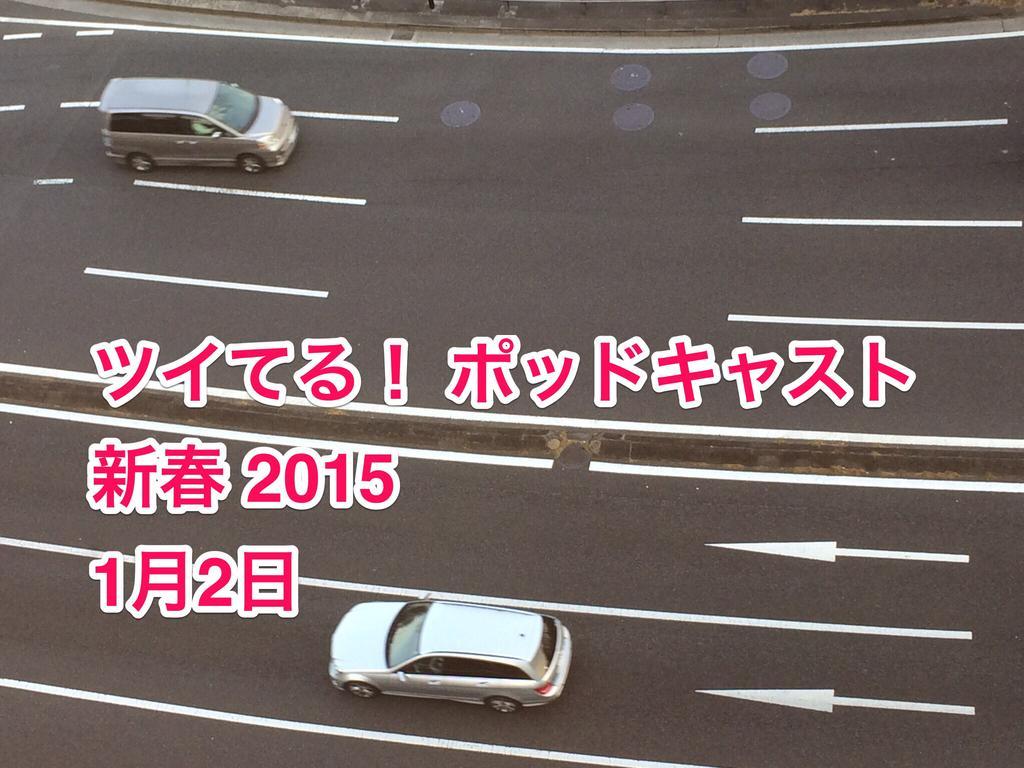Could you give a brief overview of what you see in this image? In this image there are two vehicles moving in an opposite direction on a road, in the foreground of the image there is some text. 